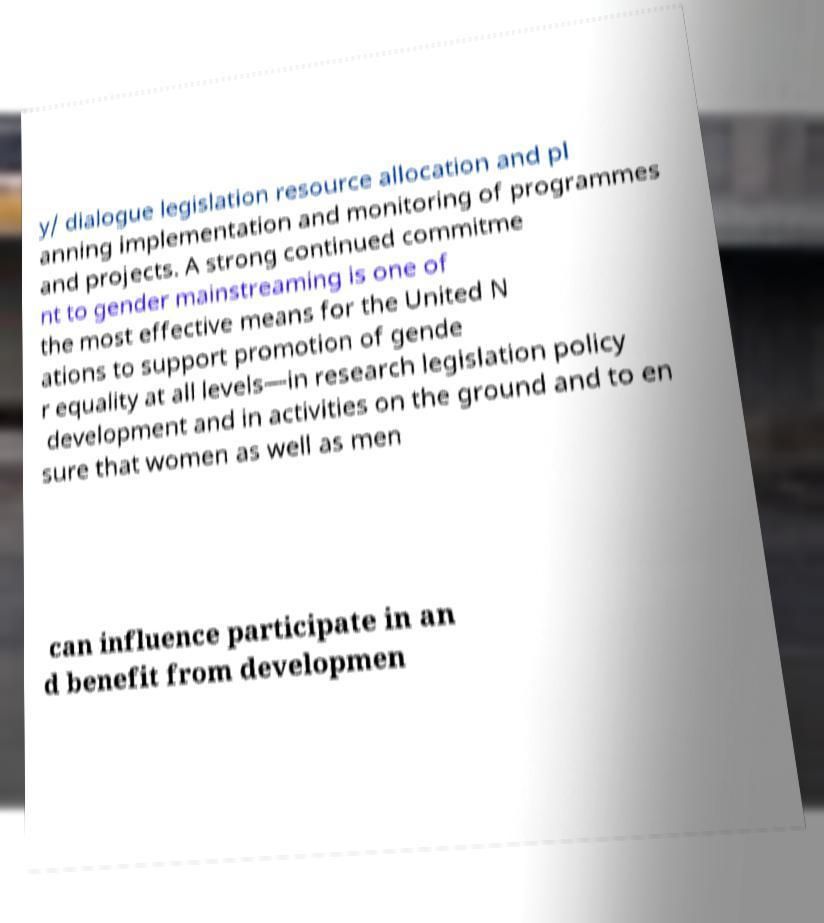Please read and relay the text visible in this image. What does it say? y/ dialogue legislation resource allocation and pl anning implementation and monitoring of programmes and projects. A strong continued commitme nt to gender mainstreaming is one of the most effective means for the United N ations to support promotion of gende r equality at all levels—in research legislation policy development and in activities on the ground and to en sure that women as well as men can influence participate in an d benefit from developmen 